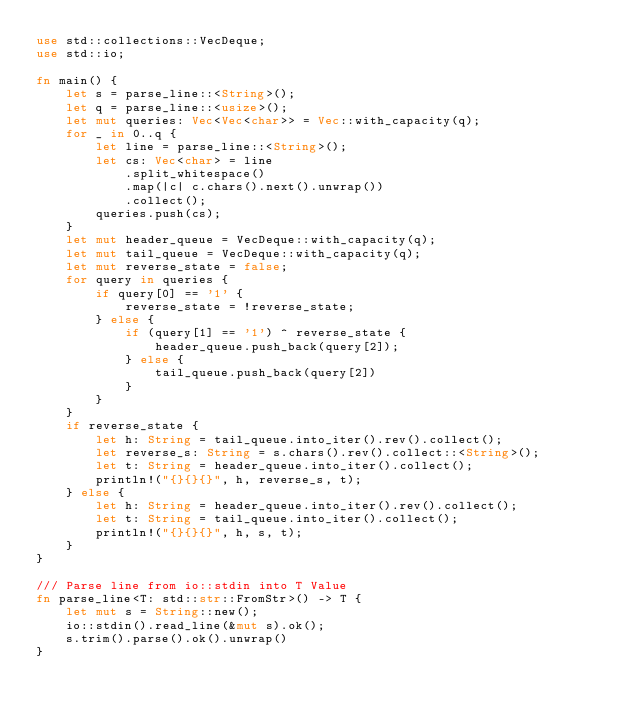<code> <loc_0><loc_0><loc_500><loc_500><_Rust_>use std::collections::VecDeque;
use std::io;

fn main() {
    let s = parse_line::<String>();
    let q = parse_line::<usize>();
    let mut queries: Vec<Vec<char>> = Vec::with_capacity(q);
    for _ in 0..q {
        let line = parse_line::<String>();
        let cs: Vec<char> = line
            .split_whitespace()
            .map(|c| c.chars().next().unwrap())
            .collect();
        queries.push(cs);
    }
    let mut header_queue = VecDeque::with_capacity(q);
    let mut tail_queue = VecDeque::with_capacity(q);
    let mut reverse_state = false;
    for query in queries {
        if query[0] == '1' {
            reverse_state = !reverse_state;
        } else {
            if (query[1] == '1') ^ reverse_state {
                header_queue.push_back(query[2]);
            } else {
                tail_queue.push_back(query[2])
            }
        }
    }
    if reverse_state {
        let h: String = tail_queue.into_iter().rev().collect();
        let reverse_s: String = s.chars().rev().collect::<String>();
        let t: String = header_queue.into_iter().collect();
        println!("{}{}{}", h, reverse_s, t);
    } else {
        let h: String = header_queue.into_iter().rev().collect();
        let t: String = tail_queue.into_iter().collect();
        println!("{}{}{}", h, s, t);
    }
}

/// Parse line from io::stdin into T Value
fn parse_line<T: std::str::FromStr>() -> T {
    let mut s = String::new();
    io::stdin().read_line(&mut s).ok();
    s.trim().parse().ok().unwrap()
}</code> 